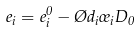<formula> <loc_0><loc_0><loc_500><loc_500>e _ { i } = e ^ { 0 } _ { i } - \chi d _ { i } \sigma _ { i } D _ { 0 }</formula> 